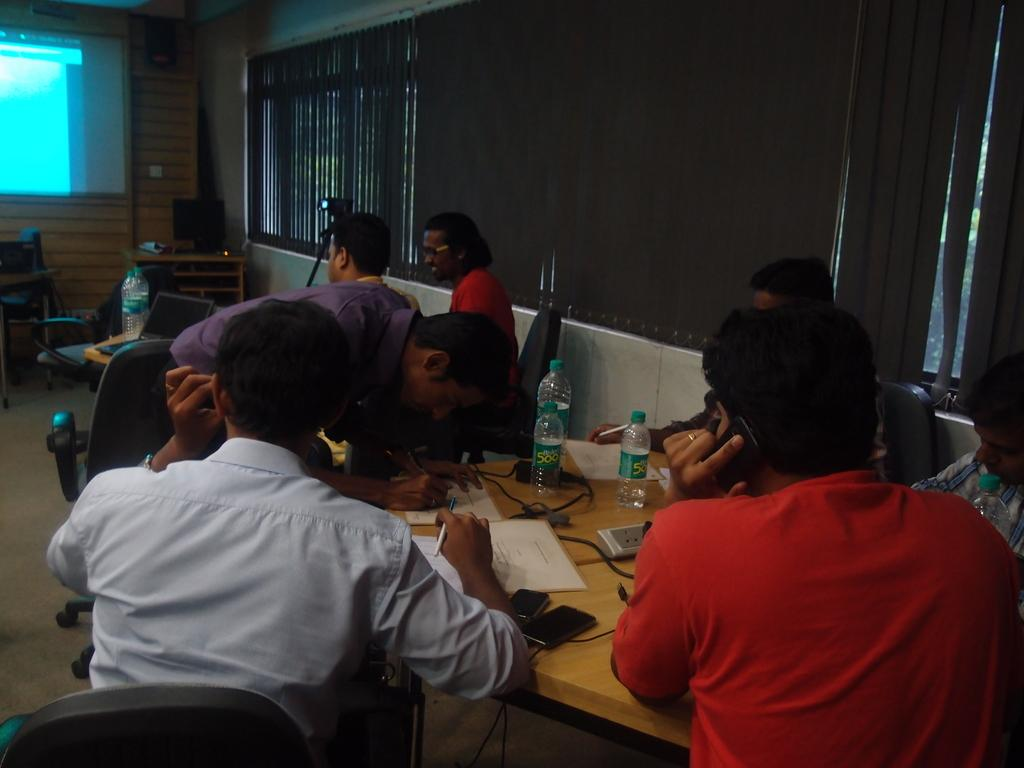What are the people in the image doing? The people in the image are sitting on chairs. What can be seen on the tables in the image? There are bottles, papers, and a laptop visible on the tables in the image. What objects are present on the tables in the image? There are objects on the tables, but the specific objects are not mentioned in the facts. What type of furniture is present in the image? Chairs are present in the image. What is visible through the window in the image? The facts do not mention what can be seen through the window. What is the background of the image? The background of the image includes a screen. What type of cake is being served on the table in the image? There is no cake present in the image. What type of chess pieces can be seen on the table in the image? There is no chess set present in the image. 